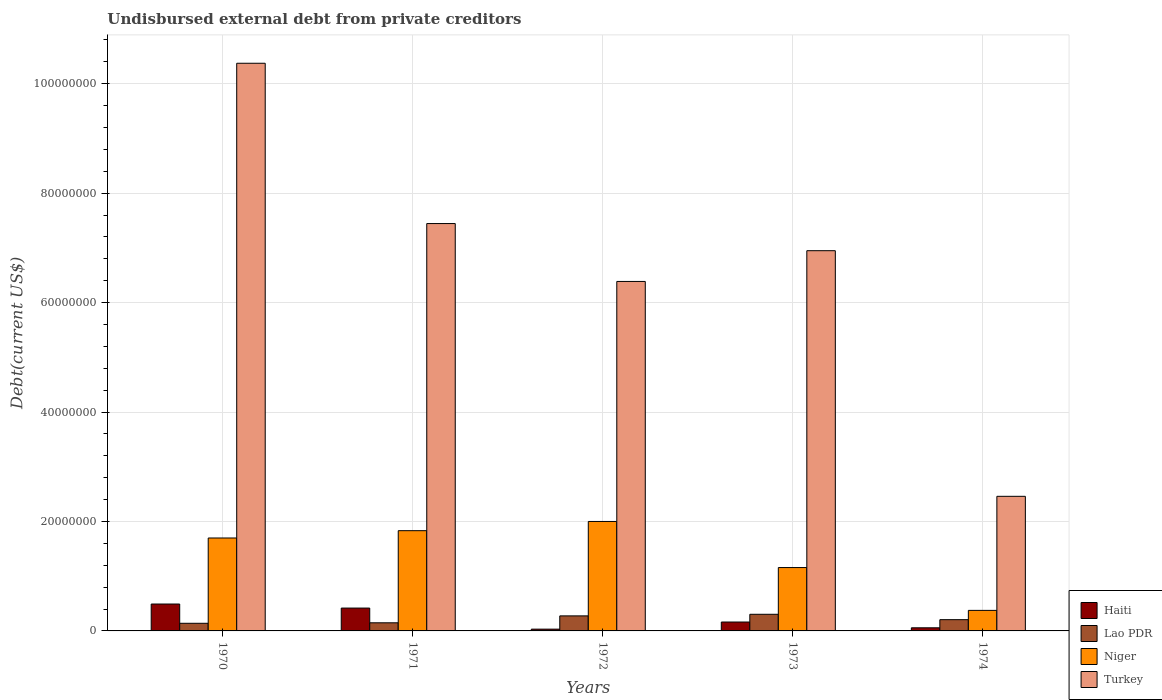How many groups of bars are there?
Ensure brevity in your answer.  5. How many bars are there on the 2nd tick from the right?
Provide a succinct answer. 4. In how many cases, is the number of bars for a given year not equal to the number of legend labels?
Your answer should be very brief. 0. What is the total debt in Niger in 1972?
Give a very brief answer. 2.00e+07. Across all years, what is the maximum total debt in Turkey?
Your response must be concise. 1.04e+08. Across all years, what is the minimum total debt in Turkey?
Provide a succinct answer. 2.46e+07. In which year was the total debt in Turkey minimum?
Keep it short and to the point. 1974. What is the total total debt in Turkey in the graph?
Provide a succinct answer. 3.36e+08. What is the difference between the total debt in Lao PDR in 1971 and that in 1972?
Your answer should be very brief. -1.26e+06. What is the difference between the total debt in Niger in 1973 and the total debt in Lao PDR in 1974?
Make the answer very short. 9.52e+06. What is the average total debt in Niger per year?
Make the answer very short. 1.41e+07. In the year 1971, what is the difference between the total debt in Lao PDR and total debt in Haiti?
Ensure brevity in your answer.  -2.69e+06. In how many years, is the total debt in Niger greater than 84000000 US$?
Keep it short and to the point. 0. What is the ratio of the total debt in Haiti in 1971 to that in 1972?
Your answer should be very brief. 12.85. Is the total debt in Niger in 1971 less than that in 1974?
Your answer should be compact. No. Is the difference between the total debt in Lao PDR in 1971 and 1973 greater than the difference between the total debt in Haiti in 1971 and 1973?
Your response must be concise. No. What is the difference between the highest and the second highest total debt in Lao PDR?
Your response must be concise. 2.92e+05. What is the difference between the highest and the lowest total debt in Lao PDR?
Keep it short and to the point. 1.64e+06. Is the sum of the total debt in Turkey in 1972 and 1974 greater than the maximum total debt in Lao PDR across all years?
Your answer should be compact. Yes. Is it the case that in every year, the sum of the total debt in Turkey and total debt in Lao PDR is greater than the sum of total debt in Niger and total debt in Haiti?
Keep it short and to the point. Yes. What does the 3rd bar from the left in 1974 represents?
Give a very brief answer. Niger. What does the 2nd bar from the right in 1972 represents?
Provide a succinct answer. Niger. How many bars are there?
Your answer should be compact. 20. Does the graph contain grids?
Offer a terse response. Yes. How many legend labels are there?
Offer a terse response. 4. What is the title of the graph?
Make the answer very short. Undisbursed external debt from private creditors. Does "Caribbean small states" appear as one of the legend labels in the graph?
Ensure brevity in your answer.  No. What is the label or title of the Y-axis?
Keep it short and to the point. Debt(current US$). What is the Debt(current US$) of Haiti in 1970?
Provide a succinct answer. 4.92e+06. What is the Debt(current US$) in Lao PDR in 1970?
Keep it short and to the point. 1.40e+06. What is the Debt(current US$) of Niger in 1970?
Your answer should be very brief. 1.70e+07. What is the Debt(current US$) of Turkey in 1970?
Offer a very short reply. 1.04e+08. What is the Debt(current US$) in Haiti in 1971?
Make the answer very short. 4.18e+06. What is the Debt(current US$) of Lao PDR in 1971?
Your answer should be compact. 1.48e+06. What is the Debt(current US$) in Niger in 1971?
Your response must be concise. 1.83e+07. What is the Debt(current US$) of Turkey in 1971?
Your answer should be very brief. 7.44e+07. What is the Debt(current US$) of Haiti in 1972?
Your answer should be very brief. 3.25e+05. What is the Debt(current US$) in Lao PDR in 1972?
Your answer should be compact. 2.75e+06. What is the Debt(current US$) of Niger in 1972?
Provide a succinct answer. 2.00e+07. What is the Debt(current US$) of Turkey in 1972?
Offer a terse response. 6.39e+07. What is the Debt(current US$) of Haiti in 1973?
Offer a terse response. 1.62e+06. What is the Debt(current US$) in Lao PDR in 1973?
Your response must be concise. 3.04e+06. What is the Debt(current US$) of Niger in 1973?
Offer a very short reply. 1.16e+07. What is the Debt(current US$) in Turkey in 1973?
Give a very brief answer. 6.95e+07. What is the Debt(current US$) in Haiti in 1974?
Keep it short and to the point. 5.69e+05. What is the Debt(current US$) of Lao PDR in 1974?
Offer a terse response. 2.06e+06. What is the Debt(current US$) in Niger in 1974?
Offer a very short reply. 3.75e+06. What is the Debt(current US$) in Turkey in 1974?
Your answer should be compact. 2.46e+07. Across all years, what is the maximum Debt(current US$) in Haiti?
Ensure brevity in your answer.  4.92e+06. Across all years, what is the maximum Debt(current US$) in Lao PDR?
Your response must be concise. 3.04e+06. Across all years, what is the maximum Debt(current US$) in Niger?
Provide a short and direct response. 2.00e+07. Across all years, what is the maximum Debt(current US$) in Turkey?
Provide a short and direct response. 1.04e+08. Across all years, what is the minimum Debt(current US$) in Haiti?
Your response must be concise. 3.25e+05. Across all years, what is the minimum Debt(current US$) in Lao PDR?
Make the answer very short. 1.40e+06. Across all years, what is the minimum Debt(current US$) in Niger?
Offer a terse response. 3.75e+06. Across all years, what is the minimum Debt(current US$) in Turkey?
Ensure brevity in your answer.  2.46e+07. What is the total Debt(current US$) of Haiti in the graph?
Offer a very short reply. 1.16e+07. What is the total Debt(current US$) of Lao PDR in the graph?
Provide a succinct answer. 1.07e+07. What is the total Debt(current US$) in Niger in the graph?
Your answer should be very brief. 7.06e+07. What is the total Debt(current US$) of Turkey in the graph?
Ensure brevity in your answer.  3.36e+08. What is the difference between the Debt(current US$) in Haiti in 1970 and that in 1971?
Your answer should be very brief. 7.40e+05. What is the difference between the Debt(current US$) of Lao PDR in 1970 and that in 1971?
Your answer should be compact. -8.90e+04. What is the difference between the Debt(current US$) of Niger in 1970 and that in 1971?
Your answer should be very brief. -1.34e+06. What is the difference between the Debt(current US$) of Turkey in 1970 and that in 1971?
Provide a succinct answer. 2.93e+07. What is the difference between the Debt(current US$) in Haiti in 1970 and that in 1972?
Keep it short and to the point. 4.59e+06. What is the difference between the Debt(current US$) of Lao PDR in 1970 and that in 1972?
Your answer should be compact. -1.35e+06. What is the difference between the Debt(current US$) in Niger in 1970 and that in 1972?
Your answer should be very brief. -3.02e+06. What is the difference between the Debt(current US$) of Turkey in 1970 and that in 1972?
Offer a very short reply. 3.99e+07. What is the difference between the Debt(current US$) of Haiti in 1970 and that in 1973?
Keep it short and to the point. 3.29e+06. What is the difference between the Debt(current US$) of Lao PDR in 1970 and that in 1973?
Offer a very short reply. -1.64e+06. What is the difference between the Debt(current US$) of Niger in 1970 and that in 1973?
Keep it short and to the point. 5.40e+06. What is the difference between the Debt(current US$) in Turkey in 1970 and that in 1973?
Offer a very short reply. 3.43e+07. What is the difference between the Debt(current US$) of Haiti in 1970 and that in 1974?
Offer a very short reply. 4.35e+06. What is the difference between the Debt(current US$) in Lao PDR in 1970 and that in 1974?
Offer a very short reply. -6.63e+05. What is the difference between the Debt(current US$) of Niger in 1970 and that in 1974?
Provide a short and direct response. 1.32e+07. What is the difference between the Debt(current US$) in Turkey in 1970 and that in 1974?
Give a very brief answer. 7.91e+07. What is the difference between the Debt(current US$) of Haiti in 1971 and that in 1972?
Your answer should be compact. 3.85e+06. What is the difference between the Debt(current US$) of Lao PDR in 1971 and that in 1972?
Your answer should be compact. -1.26e+06. What is the difference between the Debt(current US$) of Niger in 1971 and that in 1972?
Ensure brevity in your answer.  -1.68e+06. What is the difference between the Debt(current US$) in Turkey in 1971 and that in 1972?
Your answer should be compact. 1.06e+07. What is the difference between the Debt(current US$) in Haiti in 1971 and that in 1973?
Provide a succinct answer. 2.55e+06. What is the difference between the Debt(current US$) in Lao PDR in 1971 and that in 1973?
Provide a succinct answer. -1.56e+06. What is the difference between the Debt(current US$) in Niger in 1971 and that in 1973?
Provide a succinct answer. 6.74e+06. What is the difference between the Debt(current US$) in Turkey in 1971 and that in 1973?
Provide a succinct answer. 4.96e+06. What is the difference between the Debt(current US$) of Haiti in 1971 and that in 1974?
Your answer should be very brief. 3.61e+06. What is the difference between the Debt(current US$) of Lao PDR in 1971 and that in 1974?
Provide a short and direct response. -5.74e+05. What is the difference between the Debt(current US$) in Niger in 1971 and that in 1974?
Keep it short and to the point. 1.46e+07. What is the difference between the Debt(current US$) of Turkey in 1971 and that in 1974?
Ensure brevity in your answer.  4.98e+07. What is the difference between the Debt(current US$) of Haiti in 1972 and that in 1973?
Offer a terse response. -1.30e+06. What is the difference between the Debt(current US$) of Lao PDR in 1972 and that in 1973?
Your response must be concise. -2.92e+05. What is the difference between the Debt(current US$) in Niger in 1972 and that in 1973?
Your answer should be very brief. 8.42e+06. What is the difference between the Debt(current US$) in Turkey in 1972 and that in 1973?
Provide a succinct answer. -5.62e+06. What is the difference between the Debt(current US$) in Haiti in 1972 and that in 1974?
Offer a terse response. -2.44e+05. What is the difference between the Debt(current US$) of Lao PDR in 1972 and that in 1974?
Offer a terse response. 6.89e+05. What is the difference between the Debt(current US$) in Niger in 1972 and that in 1974?
Your answer should be very brief. 1.62e+07. What is the difference between the Debt(current US$) in Turkey in 1972 and that in 1974?
Your answer should be compact. 3.93e+07. What is the difference between the Debt(current US$) of Haiti in 1973 and that in 1974?
Keep it short and to the point. 1.06e+06. What is the difference between the Debt(current US$) in Lao PDR in 1973 and that in 1974?
Give a very brief answer. 9.81e+05. What is the difference between the Debt(current US$) of Niger in 1973 and that in 1974?
Offer a terse response. 7.83e+06. What is the difference between the Debt(current US$) in Turkey in 1973 and that in 1974?
Keep it short and to the point. 4.49e+07. What is the difference between the Debt(current US$) of Haiti in 1970 and the Debt(current US$) of Lao PDR in 1971?
Offer a very short reply. 3.43e+06. What is the difference between the Debt(current US$) of Haiti in 1970 and the Debt(current US$) of Niger in 1971?
Your answer should be very brief. -1.34e+07. What is the difference between the Debt(current US$) of Haiti in 1970 and the Debt(current US$) of Turkey in 1971?
Provide a succinct answer. -6.95e+07. What is the difference between the Debt(current US$) in Lao PDR in 1970 and the Debt(current US$) in Niger in 1971?
Offer a terse response. -1.69e+07. What is the difference between the Debt(current US$) in Lao PDR in 1970 and the Debt(current US$) in Turkey in 1971?
Provide a succinct answer. -7.30e+07. What is the difference between the Debt(current US$) in Niger in 1970 and the Debt(current US$) in Turkey in 1971?
Offer a very short reply. -5.75e+07. What is the difference between the Debt(current US$) in Haiti in 1970 and the Debt(current US$) in Lao PDR in 1972?
Your answer should be compact. 2.17e+06. What is the difference between the Debt(current US$) in Haiti in 1970 and the Debt(current US$) in Niger in 1972?
Offer a very short reply. -1.51e+07. What is the difference between the Debt(current US$) in Haiti in 1970 and the Debt(current US$) in Turkey in 1972?
Make the answer very short. -5.90e+07. What is the difference between the Debt(current US$) of Lao PDR in 1970 and the Debt(current US$) of Niger in 1972?
Give a very brief answer. -1.86e+07. What is the difference between the Debt(current US$) in Lao PDR in 1970 and the Debt(current US$) in Turkey in 1972?
Your response must be concise. -6.25e+07. What is the difference between the Debt(current US$) in Niger in 1970 and the Debt(current US$) in Turkey in 1972?
Provide a short and direct response. -4.69e+07. What is the difference between the Debt(current US$) of Haiti in 1970 and the Debt(current US$) of Lao PDR in 1973?
Offer a very short reply. 1.88e+06. What is the difference between the Debt(current US$) in Haiti in 1970 and the Debt(current US$) in Niger in 1973?
Keep it short and to the point. -6.66e+06. What is the difference between the Debt(current US$) of Haiti in 1970 and the Debt(current US$) of Turkey in 1973?
Keep it short and to the point. -6.46e+07. What is the difference between the Debt(current US$) in Lao PDR in 1970 and the Debt(current US$) in Niger in 1973?
Give a very brief answer. -1.02e+07. What is the difference between the Debt(current US$) of Lao PDR in 1970 and the Debt(current US$) of Turkey in 1973?
Your answer should be compact. -6.81e+07. What is the difference between the Debt(current US$) of Niger in 1970 and the Debt(current US$) of Turkey in 1973?
Your answer should be very brief. -5.25e+07. What is the difference between the Debt(current US$) of Haiti in 1970 and the Debt(current US$) of Lao PDR in 1974?
Make the answer very short. 2.86e+06. What is the difference between the Debt(current US$) of Haiti in 1970 and the Debt(current US$) of Niger in 1974?
Ensure brevity in your answer.  1.16e+06. What is the difference between the Debt(current US$) in Haiti in 1970 and the Debt(current US$) in Turkey in 1974?
Give a very brief answer. -1.97e+07. What is the difference between the Debt(current US$) of Lao PDR in 1970 and the Debt(current US$) of Niger in 1974?
Your answer should be compact. -2.36e+06. What is the difference between the Debt(current US$) in Lao PDR in 1970 and the Debt(current US$) in Turkey in 1974?
Provide a succinct answer. -2.32e+07. What is the difference between the Debt(current US$) of Niger in 1970 and the Debt(current US$) of Turkey in 1974?
Ensure brevity in your answer.  -7.62e+06. What is the difference between the Debt(current US$) of Haiti in 1971 and the Debt(current US$) of Lao PDR in 1972?
Your answer should be very brief. 1.43e+06. What is the difference between the Debt(current US$) of Haiti in 1971 and the Debt(current US$) of Niger in 1972?
Your response must be concise. -1.58e+07. What is the difference between the Debt(current US$) in Haiti in 1971 and the Debt(current US$) in Turkey in 1972?
Offer a terse response. -5.97e+07. What is the difference between the Debt(current US$) of Lao PDR in 1971 and the Debt(current US$) of Niger in 1972?
Provide a short and direct response. -1.85e+07. What is the difference between the Debt(current US$) in Lao PDR in 1971 and the Debt(current US$) in Turkey in 1972?
Your response must be concise. -6.24e+07. What is the difference between the Debt(current US$) of Niger in 1971 and the Debt(current US$) of Turkey in 1972?
Keep it short and to the point. -4.55e+07. What is the difference between the Debt(current US$) in Haiti in 1971 and the Debt(current US$) in Lao PDR in 1973?
Your answer should be very brief. 1.14e+06. What is the difference between the Debt(current US$) in Haiti in 1971 and the Debt(current US$) in Niger in 1973?
Give a very brief answer. -7.40e+06. What is the difference between the Debt(current US$) of Haiti in 1971 and the Debt(current US$) of Turkey in 1973?
Offer a very short reply. -6.53e+07. What is the difference between the Debt(current US$) in Lao PDR in 1971 and the Debt(current US$) in Niger in 1973?
Your response must be concise. -1.01e+07. What is the difference between the Debt(current US$) in Lao PDR in 1971 and the Debt(current US$) in Turkey in 1973?
Provide a succinct answer. -6.80e+07. What is the difference between the Debt(current US$) in Niger in 1971 and the Debt(current US$) in Turkey in 1973?
Offer a terse response. -5.12e+07. What is the difference between the Debt(current US$) of Haiti in 1971 and the Debt(current US$) of Lao PDR in 1974?
Offer a very short reply. 2.12e+06. What is the difference between the Debt(current US$) in Haiti in 1971 and the Debt(current US$) in Niger in 1974?
Ensure brevity in your answer.  4.22e+05. What is the difference between the Debt(current US$) of Haiti in 1971 and the Debt(current US$) of Turkey in 1974?
Your answer should be very brief. -2.04e+07. What is the difference between the Debt(current US$) in Lao PDR in 1971 and the Debt(current US$) in Niger in 1974?
Provide a succinct answer. -2.27e+06. What is the difference between the Debt(current US$) in Lao PDR in 1971 and the Debt(current US$) in Turkey in 1974?
Make the answer very short. -2.31e+07. What is the difference between the Debt(current US$) in Niger in 1971 and the Debt(current US$) in Turkey in 1974?
Make the answer very short. -6.28e+06. What is the difference between the Debt(current US$) of Haiti in 1972 and the Debt(current US$) of Lao PDR in 1973?
Provide a short and direct response. -2.71e+06. What is the difference between the Debt(current US$) in Haiti in 1972 and the Debt(current US$) in Niger in 1973?
Provide a short and direct response. -1.13e+07. What is the difference between the Debt(current US$) of Haiti in 1972 and the Debt(current US$) of Turkey in 1973?
Ensure brevity in your answer.  -6.92e+07. What is the difference between the Debt(current US$) of Lao PDR in 1972 and the Debt(current US$) of Niger in 1973?
Your answer should be very brief. -8.83e+06. What is the difference between the Debt(current US$) of Lao PDR in 1972 and the Debt(current US$) of Turkey in 1973?
Ensure brevity in your answer.  -6.67e+07. What is the difference between the Debt(current US$) of Niger in 1972 and the Debt(current US$) of Turkey in 1973?
Your answer should be compact. -4.95e+07. What is the difference between the Debt(current US$) of Haiti in 1972 and the Debt(current US$) of Lao PDR in 1974?
Your answer should be compact. -1.73e+06. What is the difference between the Debt(current US$) in Haiti in 1972 and the Debt(current US$) in Niger in 1974?
Provide a succinct answer. -3.43e+06. What is the difference between the Debt(current US$) in Haiti in 1972 and the Debt(current US$) in Turkey in 1974?
Your response must be concise. -2.43e+07. What is the difference between the Debt(current US$) in Lao PDR in 1972 and the Debt(current US$) in Niger in 1974?
Offer a terse response. -1.01e+06. What is the difference between the Debt(current US$) in Lao PDR in 1972 and the Debt(current US$) in Turkey in 1974?
Offer a very short reply. -2.19e+07. What is the difference between the Debt(current US$) in Niger in 1972 and the Debt(current US$) in Turkey in 1974?
Your answer should be compact. -4.59e+06. What is the difference between the Debt(current US$) in Haiti in 1973 and the Debt(current US$) in Lao PDR in 1974?
Ensure brevity in your answer.  -4.33e+05. What is the difference between the Debt(current US$) of Haiti in 1973 and the Debt(current US$) of Niger in 1974?
Your response must be concise. -2.13e+06. What is the difference between the Debt(current US$) in Haiti in 1973 and the Debt(current US$) in Turkey in 1974?
Keep it short and to the point. -2.30e+07. What is the difference between the Debt(current US$) of Lao PDR in 1973 and the Debt(current US$) of Niger in 1974?
Give a very brief answer. -7.15e+05. What is the difference between the Debt(current US$) of Lao PDR in 1973 and the Debt(current US$) of Turkey in 1974?
Ensure brevity in your answer.  -2.16e+07. What is the difference between the Debt(current US$) of Niger in 1973 and the Debt(current US$) of Turkey in 1974?
Offer a terse response. -1.30e+07. What is the average Debt(current US$) in Haiti per year?
Your answer should be very brief. 2.32e+06. What is the average Debt(current US$) of Lao PDR per year?
Provide a short and direct response. 2.14e+06. What is the average Debt(current US$) in Niger per year?
Ensure brevity in your answer.  1.41e+07. What is the average Debt(current US$) in Turkey per year?
Your answer should be compact. 6.72e+07. In the year 1970, what is the difference between the Debt(current US$) in Haiti and Debt(current US$) in Lao PDR?
Your answer should be very brief. 3.52e+06. In the year 1970, what is the difference between the Debt(current US$) in Haiti and Debt(current US$) in Niger?
Keep it short and to the point. -1.21e+07. In the year 1970, what is the difference between the Debt(current US$) of Haiti and Debt(current US$) of Turkey?
Your answer should be very brief. -9.88e+07. In the year 1970, what is the difference between the Debt(current US$) in Lao PDR and Debt(current US$) in Niger?
Your answer should be very brief. -1.56e+07. In the year 1970, what is the difference between the Debt(current US$) in Lao PDR and Debt(current US$) in Turkey?
Provide a succinct answer. -1.02e+08. In the year 1970, what is the difference between the Debt(current US$) in Niger and Debt(current US$) in Turkey?
Offer a terse response. -8.68e+07. In the year 1971, what is the difference between the Debt(current US$) in Haiti and Debt(current US$) in Lao PDR?
Provide a short and direct response. 2.69e+06. In the year 1971, what is the difference between the Debt(current US$) in Haiti and Debt(current US$) in Niger?
Keep it short and to the point. -1.41e+07. In the year 1971, what is the difference between the Debt(current US$) in Haiti and Debt(current US$) in Turkey?
Give a very brief answer. -7.03e+07. In the year 1971, what is the difference between the Debt(current US$) in Lao PDR and Debt(current US$) in Niger?
Your response must be concise. -1.68e+07. In the year 1971, what is the difference between the Debt(current US$) in Lao PDR and Debt(current US$) in Turkey?
Ensure brevity in your answer.  -7.30e+07. In the year 1971, what is the difference between the Debt(current US$) of Niger and Debt(current US$) of Turkey?
Your answer should be compact. -5.61e+07. In the year 1972, what is the difference between the Debt(current US$) of Haiti and Debt(current US$) of Lao PDR?
Your answer should be compact. -2.42e+06. In the year 1972, what is the difference between the Debt(current US$) in Haiti and Debt(current US$) in Niger?
Keep it short and to the point. -1.97e+07. In the year 1972, what is the difference between the Debt(current US$) in Haiti and Debt(current US$) in Turkey?
Keep it short and to the point. -6.35e+07. In the year 1972, what is the difference between the Debt(current US$) in Lao PDR and Debt(current US$) in Niger?
Provide a short and direct response. -1.73e+07. In the year 1972, what is the difference between the Debt(current US$) in Lao PDR and Debt(current US$) in Turkey?
Your answer should be very brief. -6.11e+07. In the year 1972, what is the difference between the Debt(current US$) of Niger and Debt(current US$) of Turkey?
Your answer should be compact. -4.39e+07. In the year 1973, what is the difference between the Debt(current US$) in Haiti and Debt(current US$) in Lao PDR?
Make the answer very short. -1.41e+06. In the year 1973, what is the difference between the Debt(current US$) of Haiti and Debt(current US$) of Niger?
Keep it short and to the point. -9.96e+06. In the year 1973, what is the difference between the Debt(current US$) in Haiti and Debt(current US$) in Turkey?
Provide a short and direct response. -6.79e+07. In the year 1973, what is the difference between the Debt(current US$) in Lao PDR and Debt(current US$) in Niger?
Offer a very short reply. -8.54e+06. In the year 1973, what is the difference between the Debt(current US$) in Lao PDR and Debt(current US$) in Turkey?
Give a very brief answer. -6.64e+07. In the year 1973, what is the difference between the Debt(current US$) of Niger and Debt(current US$) of Turkey?
Offer a terse response. -5.79e+07. In the year 1974, what is the difference between the Debt(current US$) in Haiti and Debt(current US$) in Lao PDR?
Your response must be concise. -1.49e+06. In the year 1974, what is the difference between the Debt(current US$) of Haiti and Debt(current US$) of Niger?
Keep it short and to the point. -3.18e+06. In the year 1974, what is the difference between the Debt(current US$) in Haiti and Debt(current US$) in Turkey?
Ensure brevity in your answer.  -2.40e+07. In the year 1974, what is the difference between the Debt(current US$) of Lao PDR and Debt(current US$) of Niger?
Your answer should be very brief. -1.70e+06. In the year 1974, what is the difference between the Debt(current US$) of Lao PDR and Debt(current US$) of Turkey?
Your answer should be very brief. -2.25e+07. In the year 1974, what is the difference between the Debt(current US$) of Niger and Debt(current US$) of Turkey?
Offer a very short reply. -2.08e+07. What is the ratio of the Debt(current US$) of Haiti in 1970 to that in 1971?
Offer a terse response. 1.18. What is the ratio of the Debt(current US$) in Lao PDR in 1970 to that in 1971?
Keep it short and to the point. 0.94. What is the ratio of the Debt(current US$) of Niger in 1970 to that in 1971?
Make the answer very short. 0.93. What is the ratio of the Debt(current US$) of Turkey in 1970 to that in 1971?
Your answer should be compact. 1.39. What is the ratio of the Debt(current US$) in Haiti in 1970 to that in 1972?
Keep it short and to the point. 15.13. What is the ratio of the Debt(current US$) in Lao PDR in 1970 to that in 1972?
Make the answer very short. 0.51. What is the ratio of the Debt(current US$) in Niger in 1970 to that in 1972?
Make the answer very short. 0.85. What is the ratio of the Debt(current US$) of Turkey in 1970 to that in 1972?
Your answer should be compact. 1.62. What is the ratio of the Debt(current US$) of Haiti in 1970 to that in 1973?
Your response must be concise. 3.03. What is the ratio of the Debt(current US$) in Lao PDR in 1970 to that in 1973?
Ensure brevity in your answer.  0.46. What is the ratio of the Debt(current US$) of Niger in 1970 to that in 1973?
Offer a terse response. 1.47. What is the ratio of the Debt(current US$) in Turkey in 1970 to that in 1973?
Make the answer very short. 1.49. What is the ratio of the Debt(current US$) in Haiti in 1970 to that in 1974?
Offer a terse response. 8.64. What is the ratio of the Debt(current US$) in Lao PDR in 1970 to that in 1974?
Provide a short and direct response. 0.68. What is the ratio of the Debt(current US$) of Niger in 1970 to that in 1974?
Your answer should be very brief. 4.52. What is the ratio of the Debt(current US$) in Turkey in 1970 to that in 1974?
Your answer should be very brief. 4.22. What is the ratio of the Debt(current US$) of Haiti in 1971 to that in 1972?
Your answer should be very brief. 12.85. What is the ratio of the Debt(current US$) of Lao PDR in 1971 to that in 1972?
Your response must be concise. 0.54. What is the ratio of the Debt(current US$) in Niger in 1971 to that in 1972?
Offer a terse response. 0.92. What is the ratio of the Debt(current US$) of Turkey in 1971 to that in 1972?
Provide a succinct answer. 1.17. What is the ratio of the Debt(current US$) of Haiti in 1971 to that in 1973?
Make the answer very short. 2.57. What is the ratio of the Debt(current US$) in Lao PDR in 1971 to that in 1973?
Give a very brief answer. 0.49. What is the ratio of the Debt(current US$) of Niger in 1971 to that in 1973?
Your answer should be compact. 1.58. What is the ratio of the Debt(current US$) in Turkey in 1971 to that in 1973?
Offer a very short reply. 1.07. What is the ratio of the Debt(current US$) of Haiti in 1971 to that in 1974?
Ensure brevity in your answer.  7.34. What is the ratio of the Debt(current US$) of Lao PDR in 1971 to that in 1974?
Your answer should be very brief. 0.72. What is the ratio of the Debt(current US$) of Niger in 1971 to that in 1974?
Your answer should be compact. 4.88. What is the ratio of the Debt(current US$) of Turkey in 1971 to that in 1974?
Your response must be concise. 3.03. What is the ratio of the Debt(current US$) in Haiti in 1972 to that in 1973?
Make the answer very short. 0.2. What is the ratio of the Debt(current US$) in Lao PDR in 1972 to that in 1973?
Your response must be concise. 0.9. What is the ratio of the Debt(current US$) in Niger in 1972 to that in 1973?
Your response must be concise. 1.73. What is the ratio of the Debt(current US$) of Turkey in 1972 to that in 1973?
Keep it short and to the point. 0.92. What is the ratio of the Debt(current US$) in Haiti in 1972 to that in 1974?
Your answer should be compact. 0.57. What is the ratio of the Debt(current US$) of Lao PDR in 1972 to that in 1974?
Offer a very short reply. 1.33. What is the ratio of the Debt(current US$) of Niger in 1972 to that in 1974?
Make the answer very short. 5.33. What is the ratio of the Debt(current US$) in Turkey in 1972 to that in 1974?
Keep it short and to the point. 2.6. What is the ratio of the Debt(current US$) of Haiti in 1973 to that in 1974?
Your response must be concise. 2.86. What is the ratio of the Debt(current US$) of Lao PDR in 1973 to that in 1974?
Your answer should be compact. 1.48. What is the ratio of the Debt(current US$) in Niger in 1973 to that in 1974?
Your answer should be very brief. 3.08. What is the ratio of the Debt(current US$) in Turkey in 1973 to that in 1974?
Your answer should be very brief. 2.82. What is the difference between the highest and the second highest Debt(current US$) in Haiti?
Give a very brief answer. 7.40e+05. What is the difference between the highest and the second highest Debt(current US$) in Lao PDR?
Provide a short and direct response. 2.92e+05. What is the difference between the highest and the second highest Debt(current US$) of Niger?
Your response must be concise. 1.68e+06. What is the difference between the highest and the second highest Debt(current US$) of Turkey?
Ensure brevity in your answer.  2.93e+07. What is the difference between the highest and the lowest Debt(current US$) of Haiti?
Your answer should be compact. 4.59e+06. What is the difference between the highest and the lowest Debt(current US$) in Lao PDR?
Your answer should be compact. 1.64e+06. What is the difference between the highest and the lowest Debt(current US$) in Niger?
Your answer should be compact. 1.62e+07. What is the difference between the highest and the lowest Debt(current US$) in Turkey?
Keep it short and to the point. 7.91e+07. 